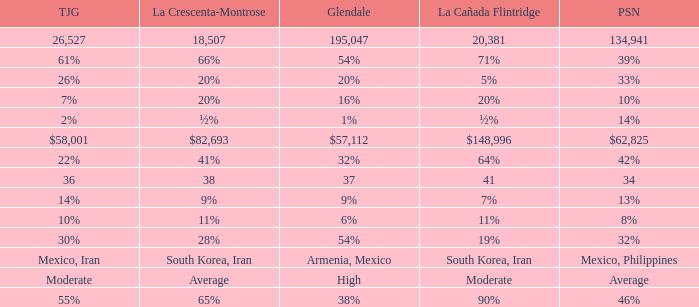When Tujunga is moderate, what is La Crescenta-Montrose? Average. 